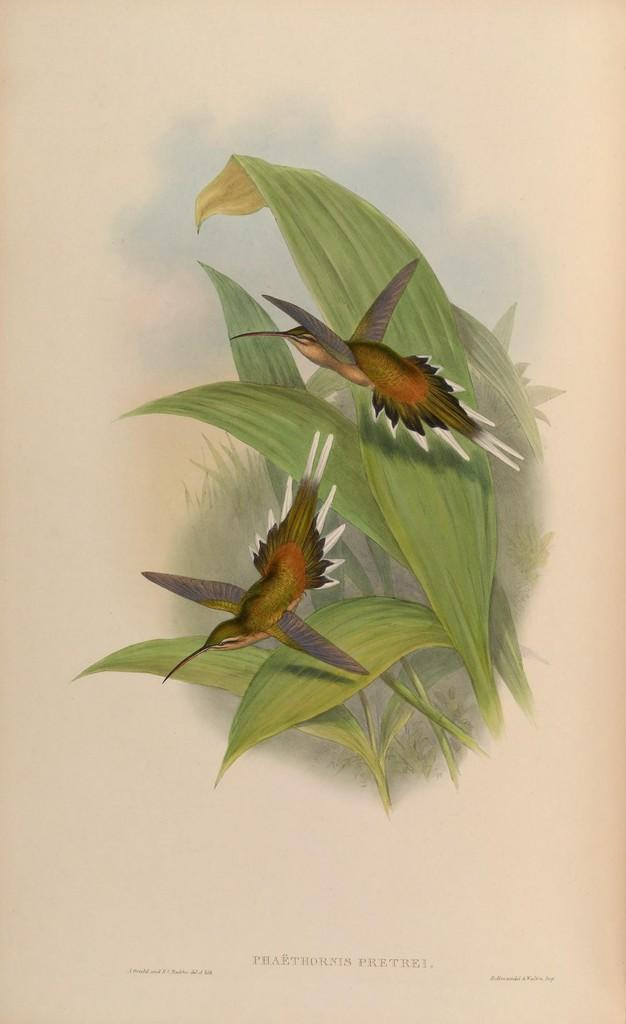What is depicted in the painting in the image? The painting in the image contains two birds and plants. Can you describe the plants in the painting? The painting contains plants, but specific details about the plants are not provided. What is written at the bottom of the image? There is some text at the bottom of the image. What type of grape is being used to connect the appliance to the power source in the image? There is no grape, connection, or appliance present in the image. 